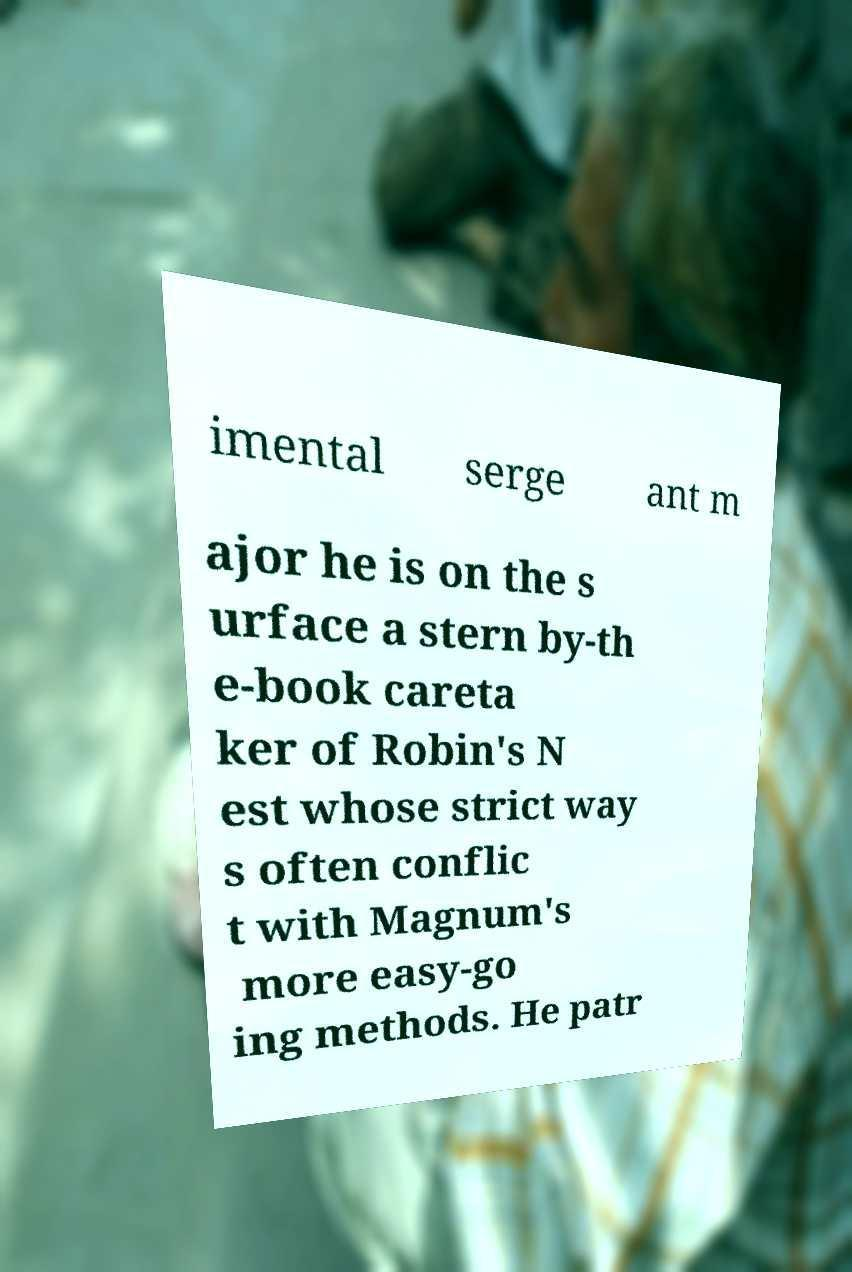Please identify and transcribe the text found in this image. imental serge ant m ajor he is on the s urface a stern by-th e-book careta ker of Robin's N est whose strict way s often conflic t with Magnum's more easy-go ing methods. He patr 